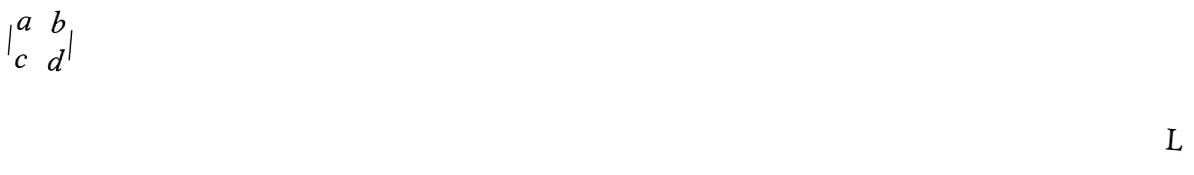Convert formula to latex. <formula><loc_0><loc_0><loc_500><loc_500>| \begin{matrix} a & b \\ c & d \end{matrix} |</formula> 